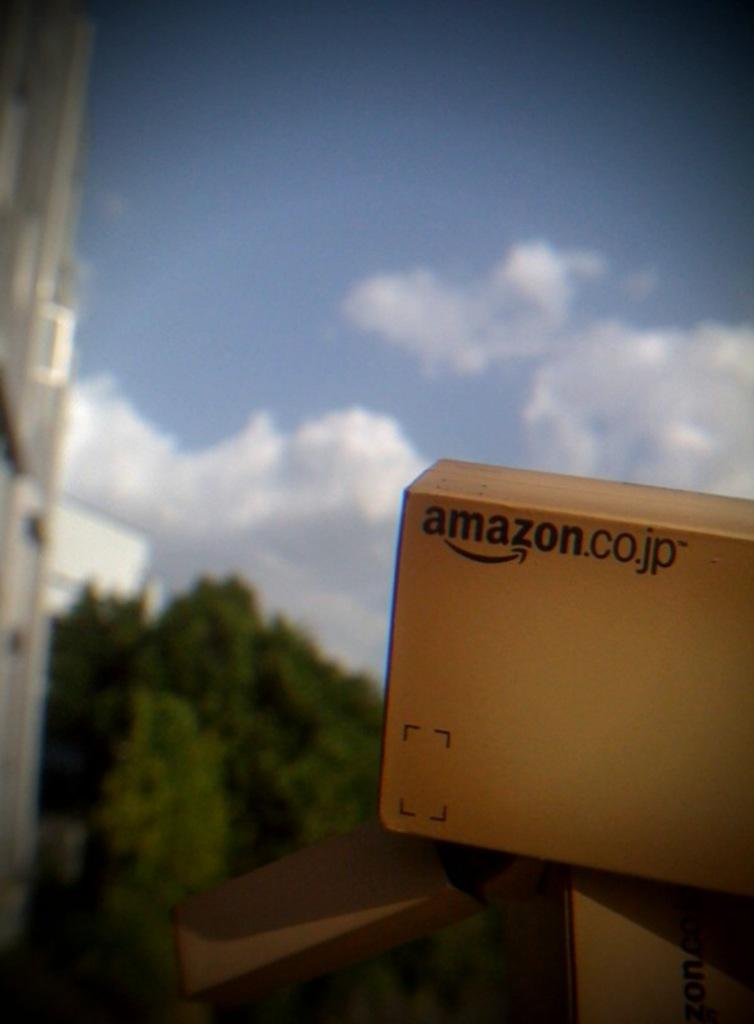What objects are located on the right side of the image? There are boxes on the right side of the image. What type of vegetation is on the left side of the image? There are trees on the left side of the image. What is visible at the top of the image? The sky is visible at the top of the image. What word is written on the boxes? The word "amazon" is written on the boxes. What type of teaching is taking place in the image? There is no teaching activity present in the image. What amusement can be seen in the image? There is no amusement depicted in the image; it features boxes, trees, and the sky. 